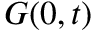<formula> <loc_0><loc_0><loc_500><loc_500>G ( 0 , t )</formula> 